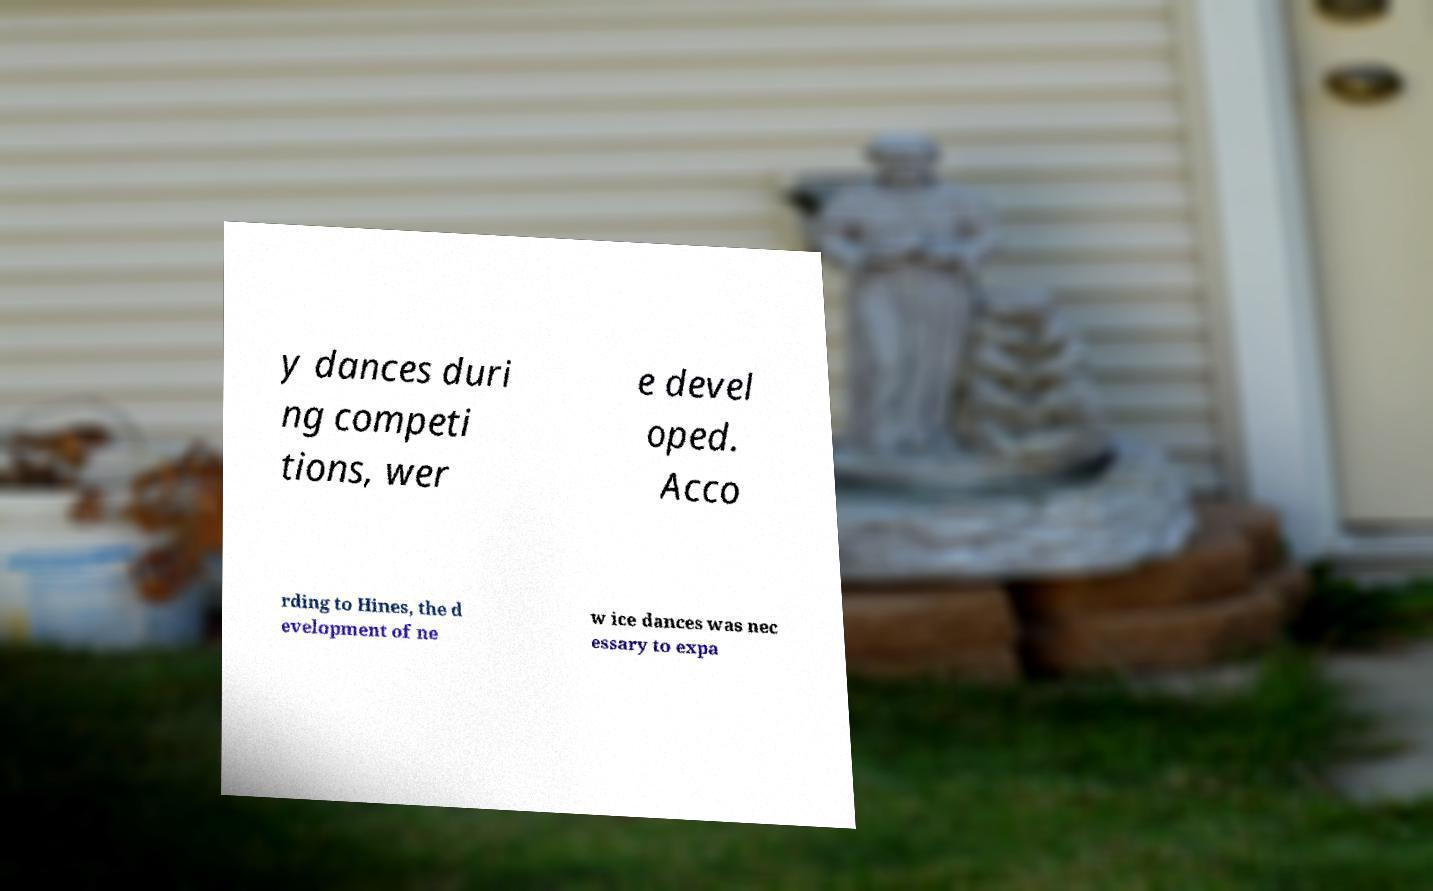Could you extract and type out the text from this image? y dances duri ng competi tions, wer e devel oped. Acco rding to Hines, the d evelopment of ne w ice dances was nec essary to expa 